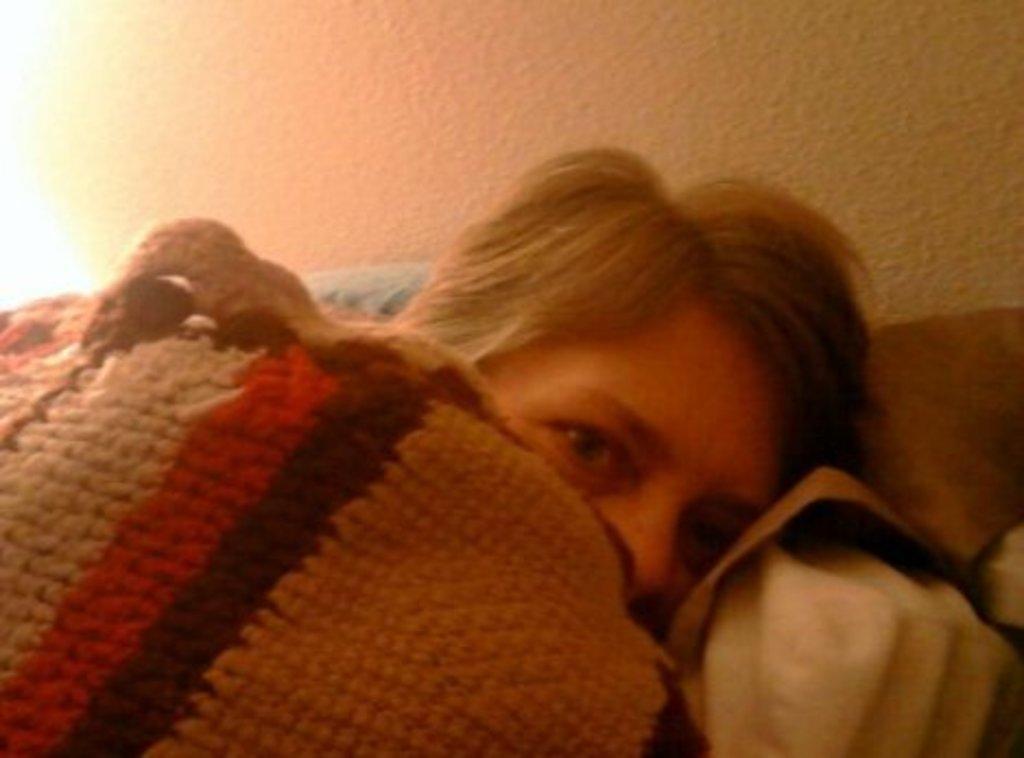Could you give a brief overview of what you see in this image? In this image we can see a person lying holding a blanket. On the backside we can see a wall. 